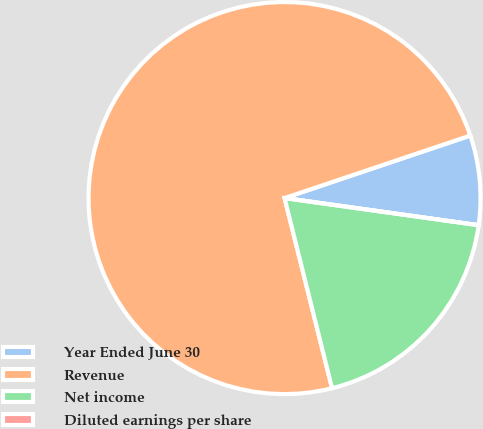Convert chart to OTSL. <chart><loc_0><loc_0><loc_500><loc_500><pie_chart><fcel>Year Ended June 30<fcel>Revenue<fcel>Net income<fcel>Diluted earnings per share<nl><fcel>7.38%<fcel>73.73%<fcel>18.89%<fcel>0.0%<nl></chart> 